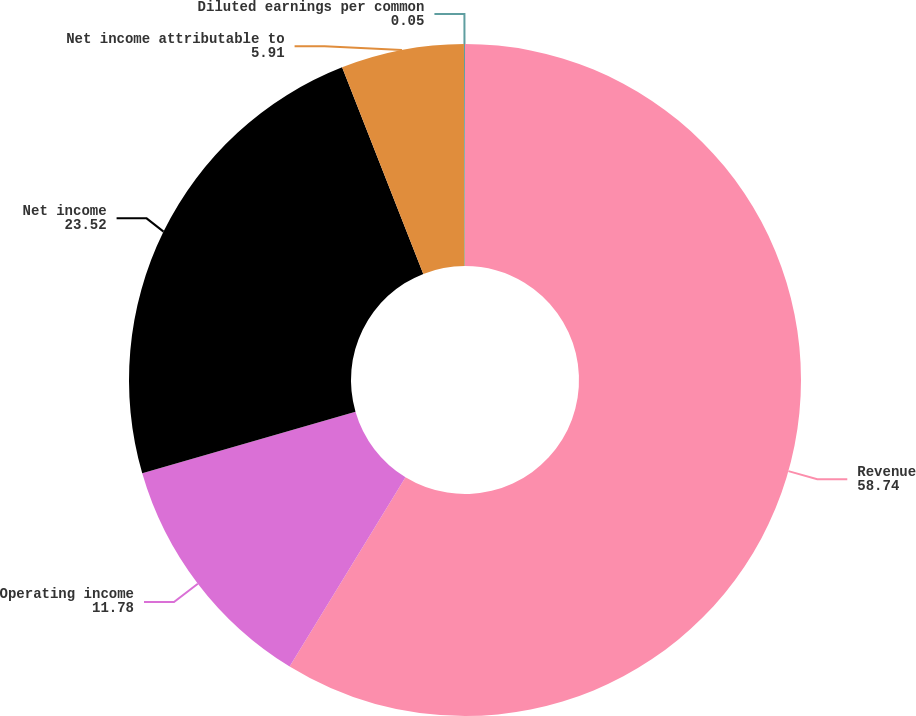Convert chart. <chart><loc_0><loc_0><loc_500><loc_500><pie_chart><fcel>Revenue<fcel>Operating income<fcel>Net income<fcel>Net income attributable to<fcel>Diluted earnings per common<nl><fcel>58.74%<fcel>11.78%<fcel>23.52%<fcel>5.91%<fcel>0.05%<nl></chart> 